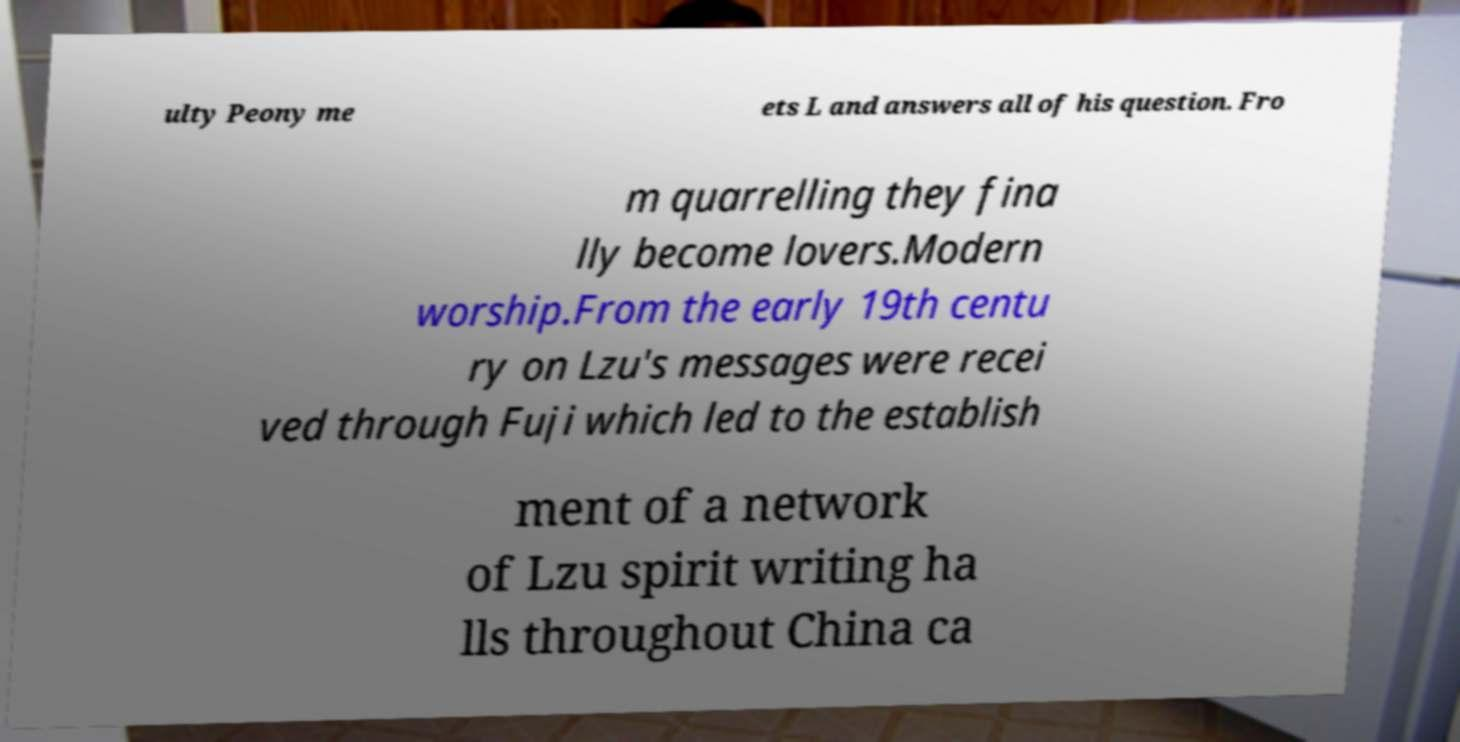For documentation purposes, I need the text within this image transcribed. Could you provide that? ulty Peony me ets L and answers all of his question. Fro m quarrelling they fina lly become lovers.Modern worship.From the early 19th centu ry on Lzu's messages were recei ved through Fuji which led to the establish ment of a network of Lzu spirit writing ha lls throughout China ca 